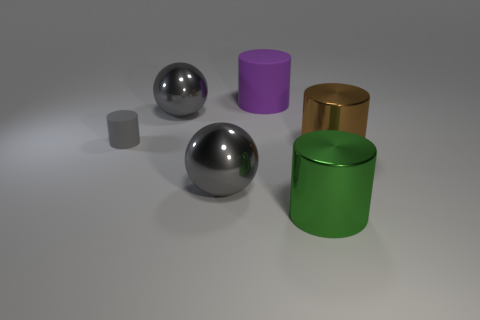Subtract 2 cylinders. How many cylinders are left? 2 Subtract all brown cylinders. How many cylinders are left? 3 Subtract all large brown cylinders. How many cylinders are left? 3 Add 4 brown metal cylinders. How many objects exist? 10 Subtract all balls. How many objects are left? 4 Subtract all green cylinders. Subtract all yellow balls. How many cylinders are left? 3 Add 2 gray matte objects. How many gray matte objects are left? 3 Add 4 tiny yellow objects. How many tiny yellow objects exist? 4 Subtract 0 red cubes. How many objects are left? 6 Subtract all brown metallic objects. Subtract all green cylinders. How many objects are left? 4 